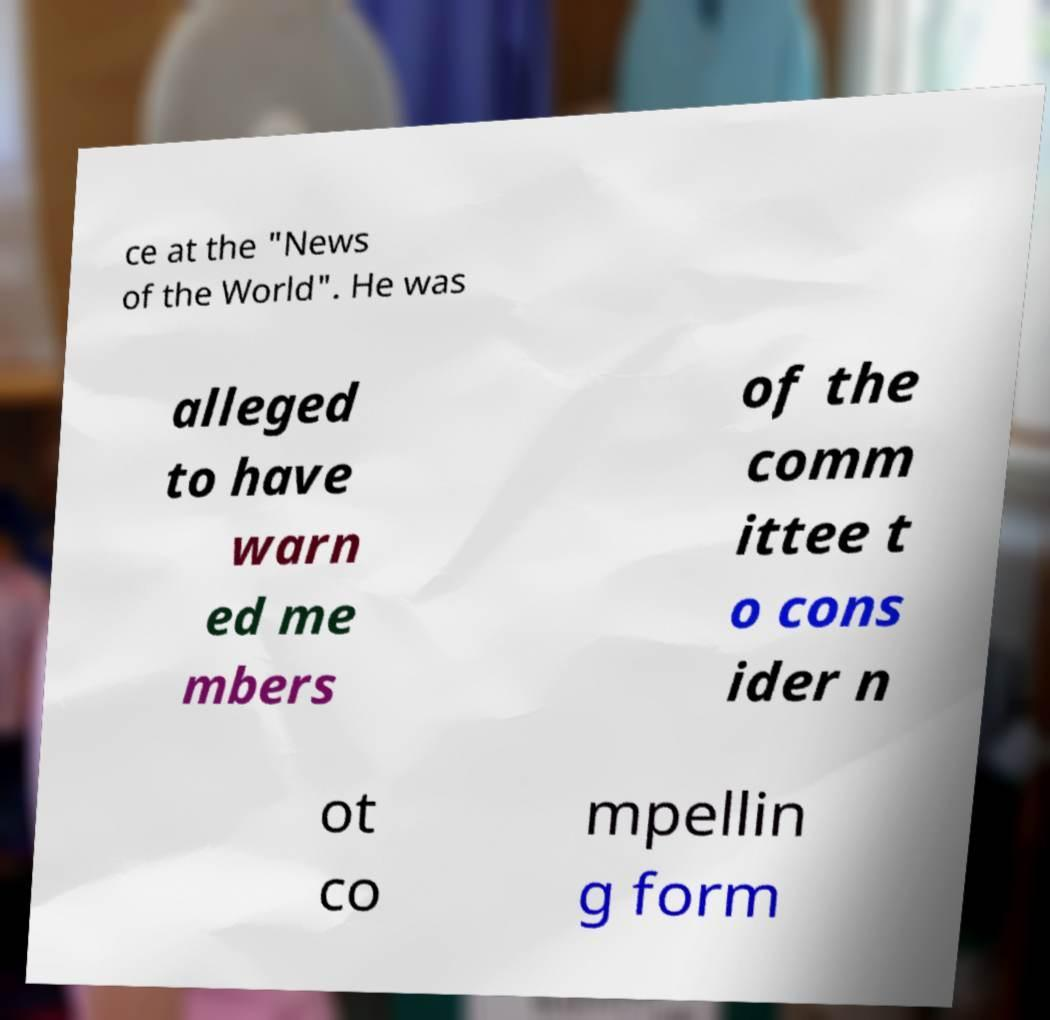There's text embedded in this image that I need extracted. Can you transcribe it verbatim? ce at the "News of the World". He was alleged to have warn ed me mbers of the comm ittee t o cons ider n ot co mpellin g form 